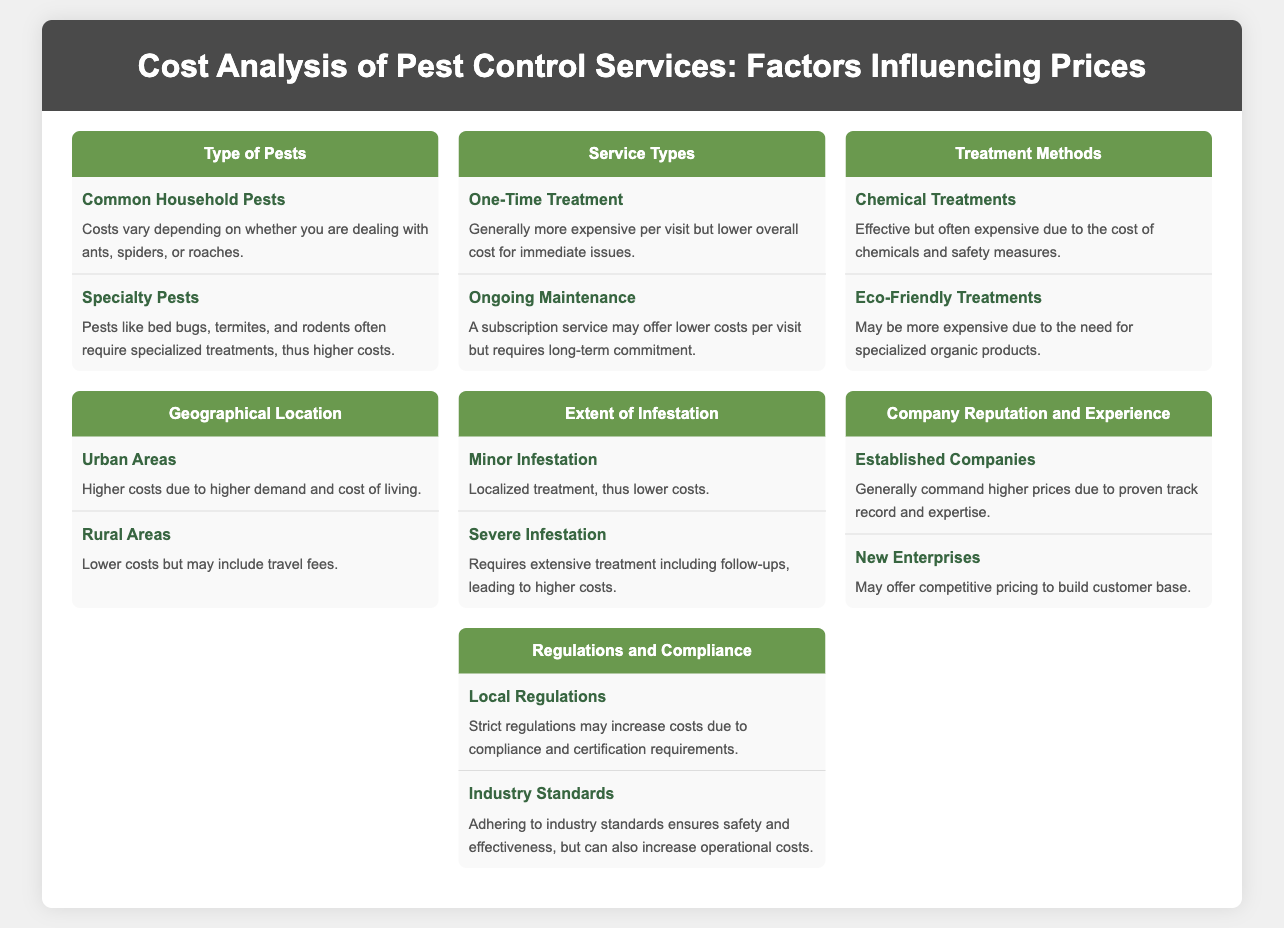What types of pests are mentioned? The infographic includes sections on common household pests and specialty pests within the "Type of Pests" section.
Answer: Common household pests, specialty pests What treatment method can be more expensive due to organic products? This question refers to the treatment methods section, which includes eco-friendly treatments that are often more costly.
Answer: Eco-Friendly Treatments What is generally more expensive per visit? This refers to the service types section, specifically pointing to the cost structure of one-time treatments.
Answer: One-Time Treatment How does the geographical location affect costs in urban areas? The urban areas subsection indicates that higher costs are a result of high demand and living costs.
Answer: Higher costs due to higher demand and cost of living What type of infestation requires extensive treatment? The extent of infestation section specifies that severe infestations necessitate more comprehensive interventions.
Answer: Severe Infestation Which type of company may offer competitive pricing? The company reputation section identifies new enterprises as potentially offering lower prices to attract customers.
Answer: New Enterprises What influence do local regulations have on pest control costs? This question pertains to the regulations section, highlighting how strict local regulations can raise costs through compliance needs.
Answer: Increase costs due to compliance requirements Which treatment method is effective but often expensive? The treatment methods section explains that chemical treatments are effective but come with higher expenses due to safety measures.
Answer: Chemical Treatments What service type may require long-term commitment? The ongoing maintenance subsection notes that this type of service typically needs an ongoing commitment from the client.
Answer: Ongoing Maintenance 